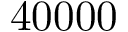<formula> <loc_0><loc_0><loc_500><loc_500>4 0 0 0 0</formula> 